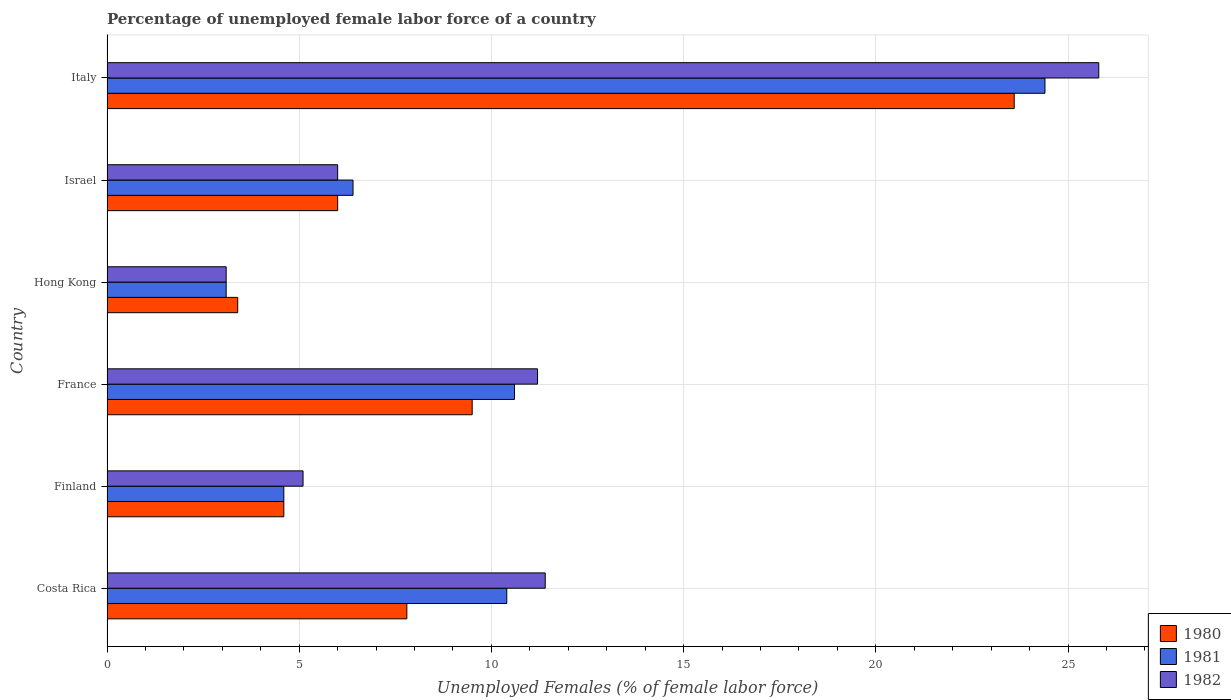How many groups of bars are there?
Make the answer very short. 6. How many bars are there on the 6th tick from the bottom?
Your response must be concise. 3. In how many cases, is the number of bars for a given country not equal to the number of legend labels?
Keep it short and to the point. 0. What is the percentage of unemployed female labor force in 1980 in Costa Rica?
Your answer should be very brief. 7.8. Across all countries, what is the maximum percentage of unemployed female labor force in 1982?
Give a very brief answer. 25.8. Across all countries, what is the minimum percentage of unemployed female labor force in 1981?
Your answer should be compact. 3.1. In which country was the percentage of unemployed female labor force in 1980 minimum?
Make the answer very short. Hong Kong. What is the total percentage of unemployed female labor force in 1980 in the graph?
Give a very brief answer. 54.9. What is the difference between the percentage of unemployed female labor force in 1981 in Finland and that in Italy?
Ensure brevity in your answer.  -19.8. What is the difference between the percentage of unemployed female labor force in 1980 in Italy and the percentage of unemployed female labor force in 1981 in Costa Rica?
Your answer should be compact. 13.2. What is the average percentage of unemployed female labor force in 1982 per country?
Your answer should be very brief. 10.43. What is the difference between the percentage of unemployed female labor force in 1982 and percentage of unemployed female labor force in 1981 in Italy?
Ensure brevity in your answer.  1.4. In how many countries, is the percentage of unemployed female labor force in 1980 greater than 24 %?
Your response must be concise. 0. What is the ratio of the percentage of unemployed female labor force in 1981 in Costa Rica to that in Italy?
Your answer should be very brief. 0.43. Is the difference between the percentage of unemployed female labor force in 1982 in Costa Rica and Israel greater than the difference between the percentage of unemployed female labor force in 1981 in Costa Rica and Israel?
Ensure brevity in your answer.  Yes. What is the difference between the highest and the second highest percentage of unemployed female labor force in 1982?
Your answer should be compact. 14.4. What is the difference between the highest and the lowest percentage of unemployed female labor force in 1980?
Provide a short and direct response. 20.2. Is it the case that in every country, the sum of the percentage of unemployed female labor force in 1981 and percentage of unemployed female labor force in 1982 is greater than the percentage of unemployed female labor force in 1980?
Your response must be concise. Yes. Are all the bars in the graph horizontal?
Give a very brief answer. Yes. How many countries are there in the graph?
Offer a very short reply. 6. Does the graph contain grids?
Provide a short and direct response. Yes. How many legend labels are there?
Provide a short and direct response. 3. How are the legend labels stacked?
Your answer should be compact. Vertical. What is the title of the graph?
Make the answer very short. Percentage of unemployed female labor force of a country. What is the label or title of the X-axis?
Ensure brevity in your answer.  Unemployed Females (% of female labor force). What is the Unemployed Females (% of female labor force) in 1980 in Costa Rica?
Offer a very short reply. 7.8. What is the Unemployed Females (% of female labor force) in 1981 in Costa Rica?
Ensure brevity in your answer.  10.4. What is the Unemployed Females (% of female labor force) in 1982 in Costa Rica?
Offer a terse response. 11.4. What is the Unemployed Females (% of female labor force) of 1980 in Finland?
Your answer should be compact. 4.6. What is the Unemployed Females (% of female labor force) of 1981 in Finland?
Make the answer very short. 4.6. What is the Unemployed Females (% of female labor force) of 1982 in Finland?
Offer a terse response. 5.1. What is the Unemployed Females (% of female labor force) in 1981 in France?
Keep it short and to the point. 10.6. What is the Unemployed Females (% of female labor force) of 1982 in France?
Provide a succinct answer. 11.2. What is the Unemployed Females (% of female labor force) of 1980 in Hong Kong?
Offer a very short reply. 3.4. What is the Unemployed Females (% of female labor force) in 1981 in Hong Kong?
Provide a short and direct response. 3.1. What is the Unemployed Females (% of female labor force) in 1982 in Hong Kong?
Offer a terse response. 3.1. What is the Unemployed Females (% of female labor force) in 1981 in Israel?
Ensure brevity in your answer.  6.4. What is the Unemployed Females (% of female labor force) in 1982 in Israel?
Your answer should be compact. 6. What is the Unemployed Females (% of female labor force) in 1980 in Italy?
Keep it short and to the point. 23.6. What is the Unemployed Females (% of female labor force) of 1981 in Italy?
Your answer should be compact. 24.4. What is the Unemployed Females (% of female labor force) in 1982 in Italy?
Provide a succinct answer. 25.8. Across all countries, what is the maximum Unemployed Females (% of female labor force) of 1980?
Your response must be concise. 23.6. Across all countries, what is the maximum Unemployed Females (% of female labor force) in 1981?
Give a very brief answer. 24.4. Across all countries, what is the maximum Unemployed Females (% of female labor force) in 1982?
Give a very brief answer. 25.8. Across all countries, what is the minimum Unemployed Females (% of female labor force) of 1980?
Make the answer very short. 3.4. Across all countries, what is the minimum Unemployed Females (% of female labor force) in 1981?
Offer a terse response. 3.1. Across all countries, what is the minimum Unemployed Females (% of female labor force) of 1982?
Your answer should be very brief. 3.1. What is the total Unemployed Females (% of female labor force) in 1980 in the graph?
Provide a succinct answer. 54.9. What is the total Unemployed Females (% of female labor force) of 1981 in the graph?
Your response must be concise. 59.5. What is the total Unemployed Females (% of female labor force) in 1982 in the graph?
Your response must be concise. 62.6. What is the difference between the Unemployed Females (% of female labor force) in 1981 in Costa Rica and that in Finland?
Your answer should be very brief. 5.8. What is the difference between the Unemployed Females (% of female labor force) of 1982 in Costa Rica and that in Finland?
Your answer should be compact. 6.3. What is the difference between the Unemployed Females (% of female labor force) of 1980 in Costa Rica and that in France?
Your answer should be compact. -1.7. What is the difference between the Unemployed Females (% of female labor force) in 1981 in Costa Rica and that in France?
Provide a succinct answer. -0.2. What is the difference between the Unemployed Females (% of female labor force) of 1982 in Costa Rica and that in France?
Keep it short and to the point. 0.2. What is the difference between the Unemployed Females (% of female labor force) of 1980 in Costa Rica and that in Hong Kong?
Your answer should be very brief. 4.4. What is the difference between the Unemployed Females (% of female labor force) in 1981 in Costa Rica and that in Hong Kong?
Your response must be concise. 7.3. What is the difference between the Unemployed Females (% of female labor force) of 1980 in Costa Rica and that in Israel?
Make the answer very short. 1.8. What is the difference between the Unemployed Females (% of female labor force) in 1981 in Costa Rica and that in Israel?
Give a very brief answer. 4. What is the difference between the Unemployed Females (% of female labor force) in 1980 in Costa Rica and that in Italy?
Give a very brief answer. -15.8. What is the difference between the Unemployed Females (% of female labor force) of 1981 in Costa Rica and that in Italy?
Give a very brief answer. -14. What is the difference between the Unemployed Females (% of female labor force) in 1982 in Costa Rica and that in Italy?
Keep it short and to the point. -14.4. What is the difference between the Unemployed Females (% of female labor force) in 1980 in Finland and that in France?
Your response must be concise. -4.9. What is the difference between the Unemployed Females (% of female labor force) in 1980 in Finland and that in Hong Kong?
Offer a terse response. 1.2. What is the difference between the Unemployed Females (% of female labor force) of 1981 in Finland and that in Hong Kong?
Offer a very short reply. 1.5. What is the difference between the Unemployed Females (% of female labor force) of 1982 in Finland and that in Hong Kong?
Ensure brevity in your answer.  2. What is the difference between the Unemployed Females (% of female labor force) of 1981 in Finland and that in Israel?
Provide a succinct answer. -1.8. What is the difference between the Unemployed Females (% of female labor force) of 1981 in Finland and that in Italy?
Give a very brief answer. -19.8. What is the difference between the Unemployed Females (% of female labor force) in 1982 in Finland and that in Italy?
Make the answer very short. -20.7. What is the difference between the Unemployed Females (% of female labor force) of 1980 in France and that in Israel?
Your response must be concise. 3.5. What is the difference between the Unemployed Females (% of female labor force) of 1980 in France and that in Italy?
Your response must be concise. -14.1. What is the difference between the Unemployed Females (% of female labor force) in 1982 in France and that in Italy?
Keep it short and to the point. -14.6. What is the difference between the Unemployed Females (% of female labor force) in 1981 in Hong Kong and that in Israel?
Provide a short and direct response. -3.3. What is the difference between the Unemployed Females (% of female labor force) of 1980 in Hong Kong and that in Italy?
Your answer should be compact. -20.2. What is the difference between the Unemployed Females (% of female labor force) of 1981 in Hong Kong and that in Italy?
Provide a short and direct response. -21.3. What is the difference between the Unemployed Females (% of female labor force) of 1982 in Hong Kong and that in Italy?
Provide a succinct answer. -22.7. What is the difference between the Unemployed Females (% of female labor force) of 1980 in Israel and that in Italy?
Your answer should be compact. -17.6. What is the difference between the Unemployed Females (% of female labor force) of 1982 in Israel and that in Italy?
Keep it short and to the point. -19.8. What is the difference between the Unemployed Females (% of female labor force) of 1981 in Costa Rica and the Unemployed Females (% of female labor force) of 1982 in Finland?
Offer a very short reply. 5.3. What is the difference between the Unemployed Females (% of female labor force) of 1980 in Costa Rica and the Unemployed Females (% of female labor force) of 1981 in France?
Keep it short and to the point. -2.8. What is the difference between the Unemployed Females (% of female labor force) of 1980 in Costa Rica and the Unemployed Females (% of female labor force) of 1982 in Hong Kong?
Offer a very short reply. 4.7. What is the difference between the Unemployed Females (% of female labor force) of 1981 in Costa Rica and the Unemployed Females (% of female labor force) of 1982 in Hong Kong?
Offer a very short reply. 7.3. What is the difference between the Unemployed Females (% of female labor force) in 1981 in Costa Rica and the Unemployed Females (% of female labor force) in 1982 in Israel?
Provide a succinct answer. 4.4. What is the difference between the Unemployed Females (% of female labor force) of 1980 in Costa Rica and the Unemployed Females (% of female labor force) of 1981 in Italy?
Provide a short and direct response. -16.6. What is the difference between the Unemployed Females (% of female labor force) of 1981 in Costa Rica and the Unemployed Females (% of female labor force) of 1982 in Italy?
Your answer should be very brief. -15.4. What is the difference between the Unemployed Females (% of female labor force) of 1980 in Finland and the Unemployed Females (% of female labor force) of 1981 in France?
Keep it short and to the point. -6. What is the difference between the Unemployed Females (% of female labor force) in 1980 in Finland and the Unemployed Females (% of female labor force) in 1982 in France?
Offer a terse response. -6.6. What is the difference between the Unemployed Females (% of female labor force) of 1980 in Finland and the Unemployed Females (% of female labor force) of 1982 in Israel?
Keep it short and to the point. -1.4. What is the difference between the Unemployed Females (% of female labor force) in 1981 in Finland and the Unemployed Females (% of female labor force) in 1982 in Israel?
Keep it short and to the point. -1.4. What is the difference between the Unemployed Females (% of female labor force) in 1980 in Finland and the Unemployed Females (% of female labor force) in 1981 in Italy?
Your response must be concise. -19.8. What is the difference between the Unemployed Females (% of female labor force) of 1980 in Finland and the Unemployed Females (% of female labor force) of 1982 in Italy?
Your response must be concise. -21.2. What is the difference between the Unemployed Females (% of female labor force) of 1981 in Finland and the Unemployed Females (% of female labor force) of 1982 in Italy?
Offer a terse response. -21.2. What is the difference between the Unemployed Females (% of female labor force) of 1980 in France and the Unemployed Females (% of female labor force) of 1982 in Hong Kong?
Your response must be concise. 6.4. What is the difference between the Unemployed Females (% of female labor force) in 1981 in France and the Unemployed Females (% of female labor force) in 1982 in Hong Kong?
Provide a succinct answer. 7.5. What is the difference between the Unemployed Females (% of female labor force) in 1980 in France and the Unemployed Females (% of female labor force) in 1981 in Israel?
Provide a succinct answer. 3.1. What is the difference between the Unemployed Females (% of female labor force) of 1981 in France and the Unemployed Females (% of female labor force) of 1982 in Israel?
Provide a short and direct response. 4.6. What is the difference between the Unemployed Females (% of female labor force) of 1980 in France and the Unemployed Females (% of female labor force) of 1981 in Italy?
Keep it short and to the point. -14.9. What is the difference between the Unemployed Females (% of female labor force) of 1980 in France and the Unemployed Females (% of female labor force) of 1982 in Italy?
Keep it short and to the point. -16.3. What is the difference between the Unemployed Females (% of female labor force) of 1981 in France and the Unemployed Females (% of female labor force) of 1982 in Italy?
Offer a terse response. -15.2. What is the difference between the Unemployed Females (% of female labor force) in 1980 in Hong Kong and the Unemployed Females (% of female labor force) in 1981 in Israel?
Ensure brevity in your answer.  -3. What is the difference between the Unemployed Females (% of female labor force) in 1980 in Hong Kong and the Unemployed Females (% of female labor force) in 1982 in Israel?
Your answer should be compact. -2.6. What is the difference between the Unemployed Females (% of female labor force) of 1980 in Hong Kong and the Unemployed Females (% of female labor force) of 1981 in Italy?
Your answer should be compact. -21. What is the difference between the Unemployed Females (% of female labor force) in 1980 in Hong Kong and the Unemployed Females (% of female labor force) in 1982 in Italy?
Provide a short and direct response. -22.4. What is the difference between the Unemployed Females (% of female labor force) in 1981 in Hong Kong and the Unemployed Females (% of female labor force) in 1982 in Italy?
Make the answer very short. -22.7. What is the difference between the Unemployed Females (% of female labor force) in 1980 in Israel and the Unemployed Females (% of female labor force) in 1981 in Italy?
Provide a short and direct response. -18.4. What is the difference between the Unemployed Females (% of female labor force) of 1980 in Israel and the Unemployed Females (% of female labor force) of 1982 in Italy?
Your response must be concise. -19.8. What is the difference between the Unemployed Females (% of female labor force) of 1981 in Israel and the Unemployed Females (% of female labor force) of 1982 in Italy?
Your answer should be very brief. -19.4. What is the average Unemployed Females (% of female labor force) of 1980 per country?
Give a very brief answer. 9.15. What is the average Unemployed Females (% of female labor force) of 1981 per country?
Keep it short and to the point. 9.92. What is the average Unemployed Females (% of female labor force) of 1982 per country?
Ensure brevity in your answer.  10.43. What is the difference between the Unemployed Females (% of female labor force) in 1980 and Unemployed Females (% of female labor force) in 1981 in Costa Rica?
Give a very brief answer. -2.6. What is the difference between the Unemployed Females (% of female labor force) of 1980 and Unemployed Females (% of female labor force) of 1982 in Costa Rica?
Your answer should be very brief. -3.6. What is the difference between the Unemployed Females (% of female labor force) of 1980 and Unemployed Females (% of female labor force) of 1981 in Finland?
Your answer should be very brief. 0. What is the difference between the Unemployed Females (% of female labor force) of 1981 and Unemployed Females (% of female labor force) of 1982 in Finland?
Give a very brief answer. -0.5. What is the difference between the Unemployed Females (% of female labor force) of 1980 and Unemployed Females (% of female labor force) of 1982 in France?
Your answer should be very brief. -1.7. What is the difference between the Unemployed Females (% of female labor force) of 1981 and Unemployed Females (% of female labor force) of 1982 in France?
Provide a succinct answer. -0.6. What is the difference between the Unemployed Females (% of female labor force) in 1981 and Unemployed Females (% of female labor force) in 1982 in Hong Kong?
Your answer should be compact. 0. What is the difference between the Unemployed Females (% of female labor force) in 1980 and Unemployed Females (% of female labor force) in 1982 in Israel?
Keep it short and to the point. 0. What is the difference between the Unemployed Females (% of female labor force) of 1980 and Unemployed Females (% of female labor force) of 1982 in Italy?
Your response must be concise. -2.2. What is the ratio of the Unemployed Females (% of female labor force) of 1980 in Costa Rica to that in Finland?
Keep it short and to the point. 1.7. What is the ratio of the Unemployed Females (% of female labor force) of 1981 in Costa Rica to that in Finland?
Your response must be concise. 2.26. What is the ratio of the Unemployed Females (% of female labor force) in 1982 in Costa Rica to that in Finland?
Your answer should be very brief. 2.24. What is the ratio of the Unemployed Females (% of female labor force) of 1980 in Costa Rica to that in France?
Offer a very short reply. 0.82. What is the ratio of the Unemployed Females (% of female labor force) in 1981 in Costa Rica to that in France?
Provide a succinct answer. 0.98. What is the ratio of the Unemployed Females (% of female labor force) in 1982 in Costa Rica to that in France?
Make the answer very short. 1.02. What is the ratio of the Unemployed Females (% of female labor force) in 1980 in Costa Rica to that in Hong Kong?
Provide a short and direct response. 2.29. What is the ratio of the Unemployed Females (% of female labor force) of 1981 in Costa Rica to that in Hong Kong?
Offer a terse response. 3.35. What is the ratio of the Unemployed Females (% of female labor force) of 1982 in Costa Rica to that in Hong Kong?
Make the answer very short. 3.68. What is the ratio of the Unemployed Females (% of female labor force) of 1980 in Costa Rica to that in Israel?
Provide a succinct answer. 1.3. What is the ratio of the Unemployed Females (% of female labor force) of 1981 in Costa Rica to that in Israel?
Provide a short and direct response. 1.62. What is the ratio of the Unemployed Females (% of female labor force) of 1982 in Costa Rica to that in Israel?
Provide a short and direct response. 1.9. What is the ratio of the Unemployed Females (% of female labor force) in 1980 in Costa Rica to that in Italy?
Offer a very short reply. 0.33. What is the ratio of the Unemployed Females (% of female labor force) of 1981 in Costa Rica to that in Italy?
Make the answer very short. 0.43. What is the ratio of the Unemployed Females (% of female labor force) in 1982 in Costa Rica to that in Italy?
Give a very brief answer. 0.44. What is the ratio of the Unemployed Females (% of female labor force) of 1980 in Finland to that in France?
Keep it short and to the point. 0.48. What is the ratio of the Unemployed Females (% of female labor force) in 1981 in Finland to that in France?
Keep it short and to the point. 0.43. What is the ratio of the Unemployed Females (% of female labor force) in 1982 in Finland to that in France?
Make the answer very short. 0.46. What is the ratio of the Unemployed Females (% of female labor force) of 1980 in Finland to that in Hong Kong?
Make the answer very short. 1.35. What is the ratio of the Unemployed Females (% of female labor force) of 1981 in Finland to that in Hong Kong?
Keep it short and to the point. 1.48. What is the ratio of the Unemployed Females (% of female labor force) in 1982 in Finland to that in Hong Kong?
Your answer should be very brief. 1.65. What is the ratio of the Unemployed Females (% of female labor force) in 1980 in Finland to that in Israel?
Your answer should be compact. 0.77. What is the ratio of the Unemployed Females (% of female labor force) in 1981 in Finland to that in Israel?
Keep it short and to the point. 0.72. What is the ratio of the Unemployed Females (% of female labor force) in 1980 in Finland to that in Italy?
Your answer should be very brief. 0.19. What is the ratio of the Unemployed Females (% of female labor force) in 1981 in Finland to that in Italy?
Your answer should be compact. 0.19. What is the ratio of the Unemployed Females (% of female labor force) of 1982 in Finland to that in Italy?
Offer a terse response. 0.2. What is the ratio of the Unemployed Females (% of female labor force) of 1980 in France to that in Hong Kong?
Provide a succinct answer. 2.79. What is the ratio of the Unemployed Females (% of female labor force) in 1981 in France to that in Hong Kong?
Ensure brevity in your answer.  3.42. What is the ratio of the Unemployed Females (% of female labor force) in 1982 in France to that in Hong Kong?
Provide a short and direct response. 3.61. What is the ratio of the Unemployed Females (% of female labor force) of 1980 in France to that in Israel?
Keep it short and to the point. 1.58. What is the ratio of the Unemployed Females (% of female labor force) of 1981 in France to that in Israel?
Offer a very short reply. 1.66. What is the ratio of the Unemployed Females (% of female labor force) in 1982 in France to that in Israel?
Your answer should be compact. 1.87. What is the ratio of the Unemployed Females (% of female labor force) of 1980 in France to that in Italy?
Ensure brevity in your answer.  0.4. What is the ratio of the Unemployed Females (% of female labor force) of 1981 in France to that in Italy?
Ensure brevity in your answer.  0.43. What is the ratio of the Unemployed Females (% of female labor force) in 1982 in France to that in Italy?
Your response must be concise. 0.43. What is the ratio of the Unemployed Females (% of female labor force) of 1980 in Hong Kong to that in Israel?
Keep it short and to the point. 0.57. What is the ratio of the Unemployed Females (% of female labor force) of 1981 in Hong Kong to that in Israel?
Your answer should be very brief. 0.48. What is the ratio of the Unemployed Females (% of female labor force) in 1982 in Hong Kong to that in Israel?
Give a very brief answer. 0.52. What is the ratio of the Unemployed Females (% of female labor force) of 1980 in Hong Kong to that in Italy?
Offer a terse response. 0.14. What is the ratio of the Unemployed Females (% of female labor force) in 1981 in Hong Kong to that in Italy?
Your answer should be very brief. 0.13. What is the ratio of the Unemployed Females (% of female labor force) of 1982 in Hong Kong to that in Italy?
Ensure brevity in your answer.  0.12. What is the ratio of the Unemployed Females (% of female labor force) in 1980 in Israel to that in Italy?
Keep it short and to the point. 0.25. What is the ratio of the Unemployed Females (% of female labor force) of 1981 in Israel to that in Italy?
Give a very brief answer. 0.26. What is the ratio of the Unemployed Females (% of female labor force) in 1982 in Israel to that in Italy?
Provide a succinct answer. 0.23. What is the difference between the highest and the second highest Unemployed Females (% of female labor force) in 1982?
Provide a short and direct response. 14.4. What is the difference between the highest and the lowest Unemployed Females (% of female labor force) of 1980?
Keep it short and to the point. 20.2. What is the difference between the highest and the lowest Unemployed Females (% of female labor force) of 1981?
Provide a succinct answer. 21.3. What is the difference between the highest and the lowest Unemployed Females (% of female labor force) of 1982?
Your answer should be compact. 22.7. 